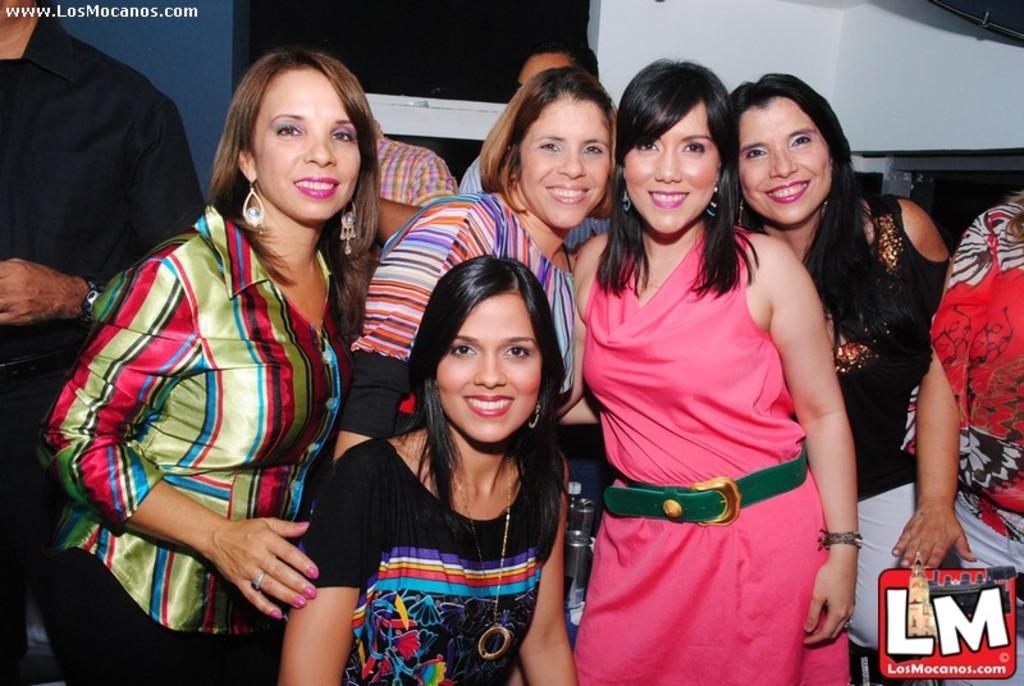Can you describe this image briefly? This image consists of many girls. In the front, the woman is wearing black dress. In the background, there is a wall along with a window. To the left, there is a man standing. 